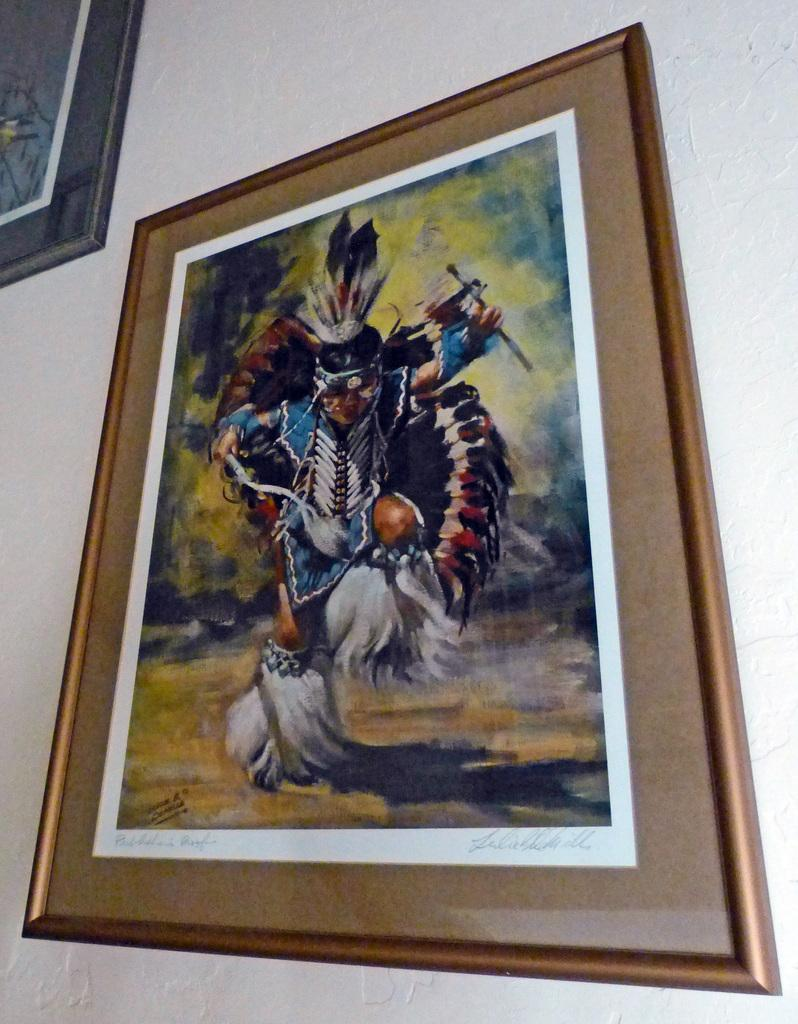What is hanging on the wall in the image? There are frames on the wall in the image. What type of metal is used to create the sun in the image? There is no sun present in the image, and therefore no metal can be associated with it. 